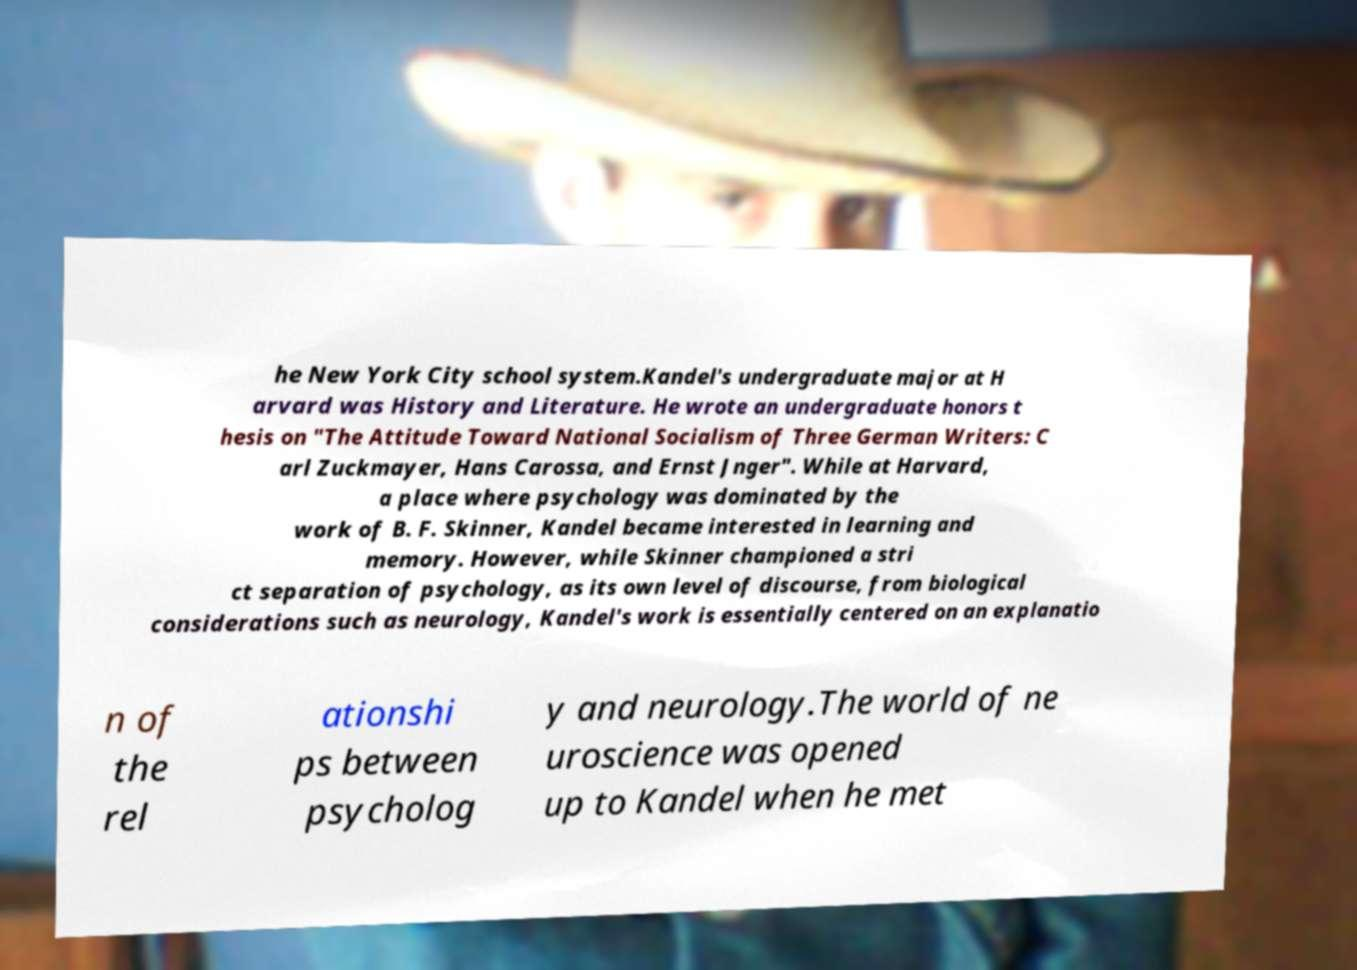I need the written content from this picture converted into text. Can you do that? he New York City school system.Kandel's undergraduate major at H arvard was History and Literature. He wrote an undergraduate honors t hesis on "The Attitude Toward National Socialism of Three German Writers: C arl Zuckmayer, Hans Carossa, and Ernst Jnger". While at Harvard, a place where psychology was dominated by the work of B. F. Skinner, Kandel became interested in learning and memory. However, while Skinner championed a stri ct separation of psychology, as its own level of discourse, from biological considerations such as neurology, Kandel's work is essentially centered on an explanatio n of the rel ationshi ps between psycholog y and neurology.The world of ne uroscience was opened up to Kandel when he met 